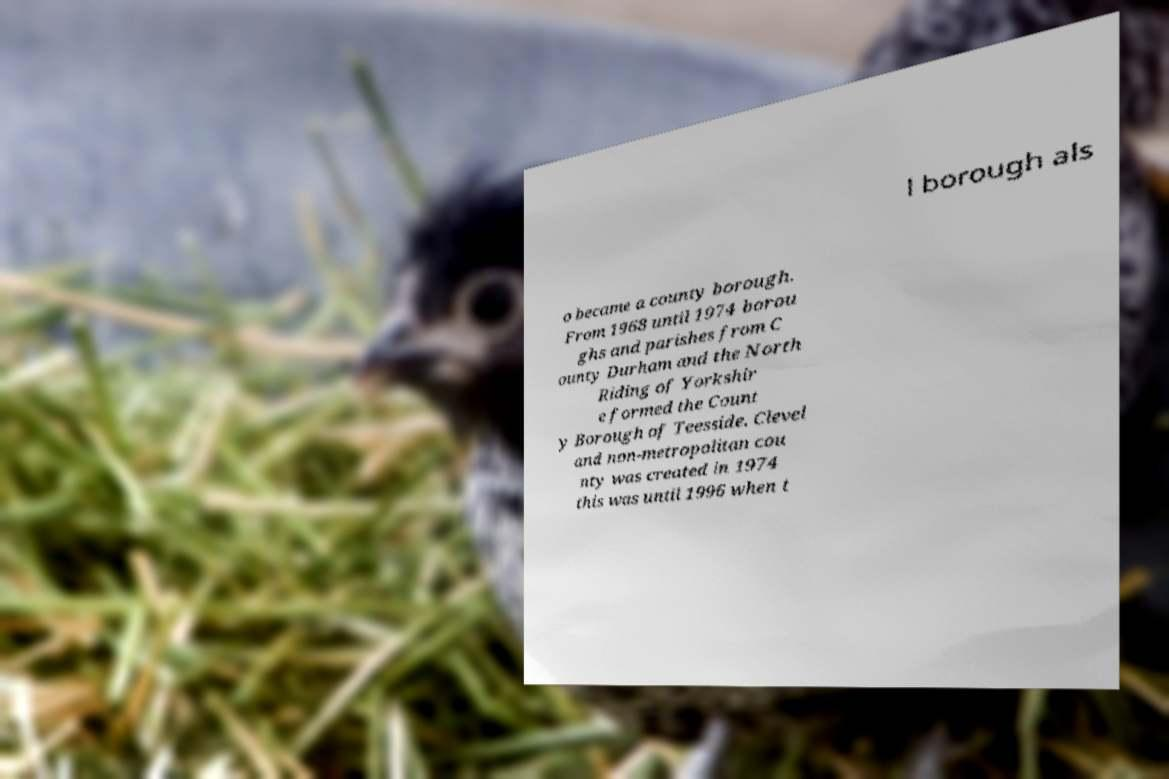Could you assist in decoding the text presented in this image and type it out clearly? l borough als o became a county borough. From 1968 until 1974 borou ghs and parishes from C ounty Durham and the North Riding of Yorkshir e formed the Count y Borough of Teesside. Clevel and non-metropolitan cou nty was created in 1974 this was until 1996 when t 